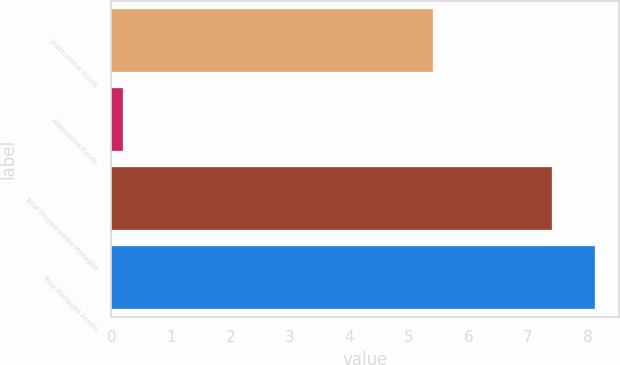Convert chart to OTSL. <chart><loc_0><loc_0><loc_500><loc_500><bar_chart><fcel>Institutional Funds<fcel>Alternative Funds<fcel>Total Threadneedle Managed<fcel>Total Managed Assets<nl><fcel>5.4<fcel>0.2<fcel>7.4<fcel>8.12<nl></chart> 